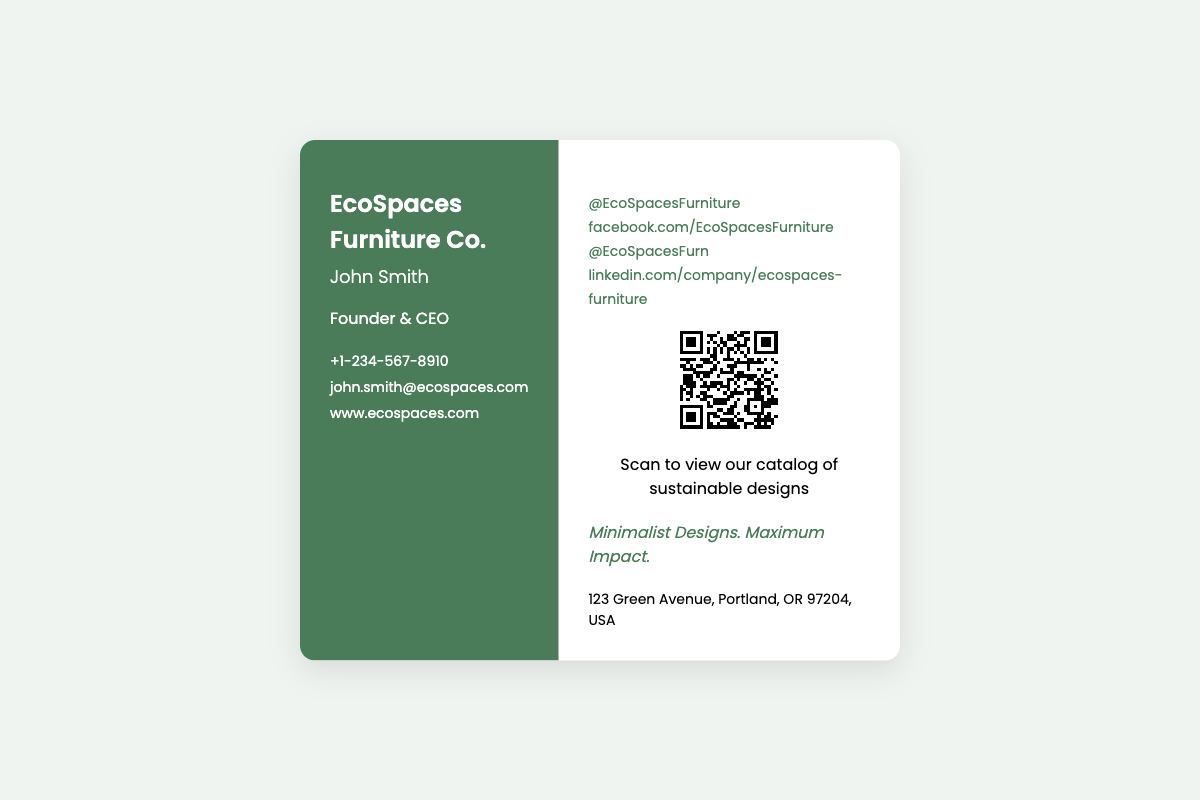What is the name of the company? The company name is prominently displayed at the top left of the card.
Answer: EcoSpaces Furniture Co Who is the founder of the company? The founder's name is listed below the company name on the left side of the card.
Answer: John Smith What is the phone number listed? The contact information section includes a phone number mentioned with a "+" sign.
Answer: +1-234-567-8910 What slogan is featured on the card? The slogan is located towards the bottom right of the card.
Answer: Minimalist Designs. Maximum Impact How many social media links are provided? The social media section can be counted for the number of links provided.
Answer: 4 What does the QR code link to? The caption below the QR code indicates what scanning it will lead to.
Answer: sustainable designs catalog Where is the company located? The address is provided at the bottom right of the card.
Answer: 123 Green Avenue, Portland, OR 97204, USA What color is the left side of the card? The background color of the left side can be identified visually from the design.
Answer: Dark green What is the website for EcoSpaces Furniture Co.? The website is listed in the contact information section of the left side.
Answer: www.ecospaces.com 